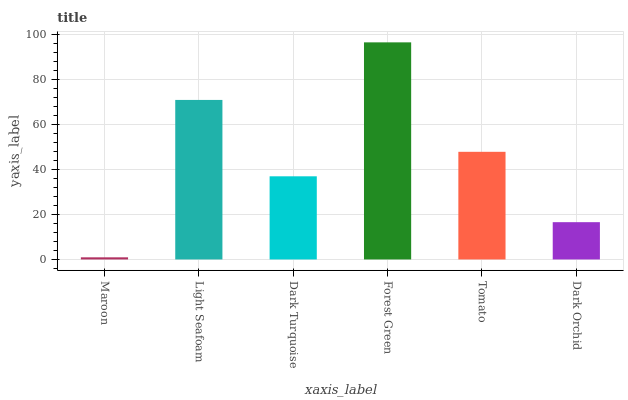Is Maroon the minimum?
Answer yes or no. Yes. Is Forest Green the maximum?
Answer yes or no. Yes. Is Light Seafoam the minimum?
Answer yes or no. No. Is Light Seafoam the maximum?
Answer yes or no. No. Is Light Seafoam greater than Maroon?
Answer yes or no. Yes. Is Maroon less than Light Seafoam?
Answer yes or no. Yes. Is Maroon greater than Light Seafoam?
Answer yes or no. No. Is Light Seafoam less than Maroon?
Answer yes or no. No. Is Tomato the high median?
Answer yes or no. Yes. Is Dark Turquoise the low median?
Answer yes or no. Yes. Is Forest Green the high median?
Answer yes or no. No. Is Dark Orchid the low median?
Answer yes or no. No. 